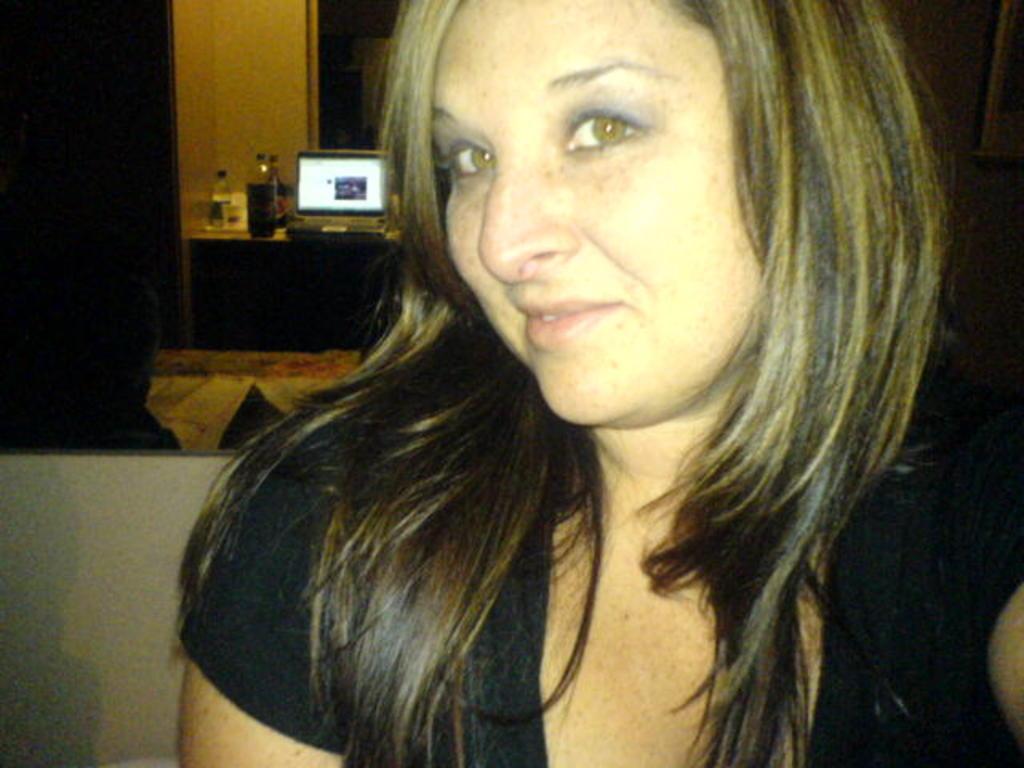In one or two sentences, can you explain what this image depicts? In this image there is a woman in the middle. In the background there is a table on which there are bottles and a laptop. 